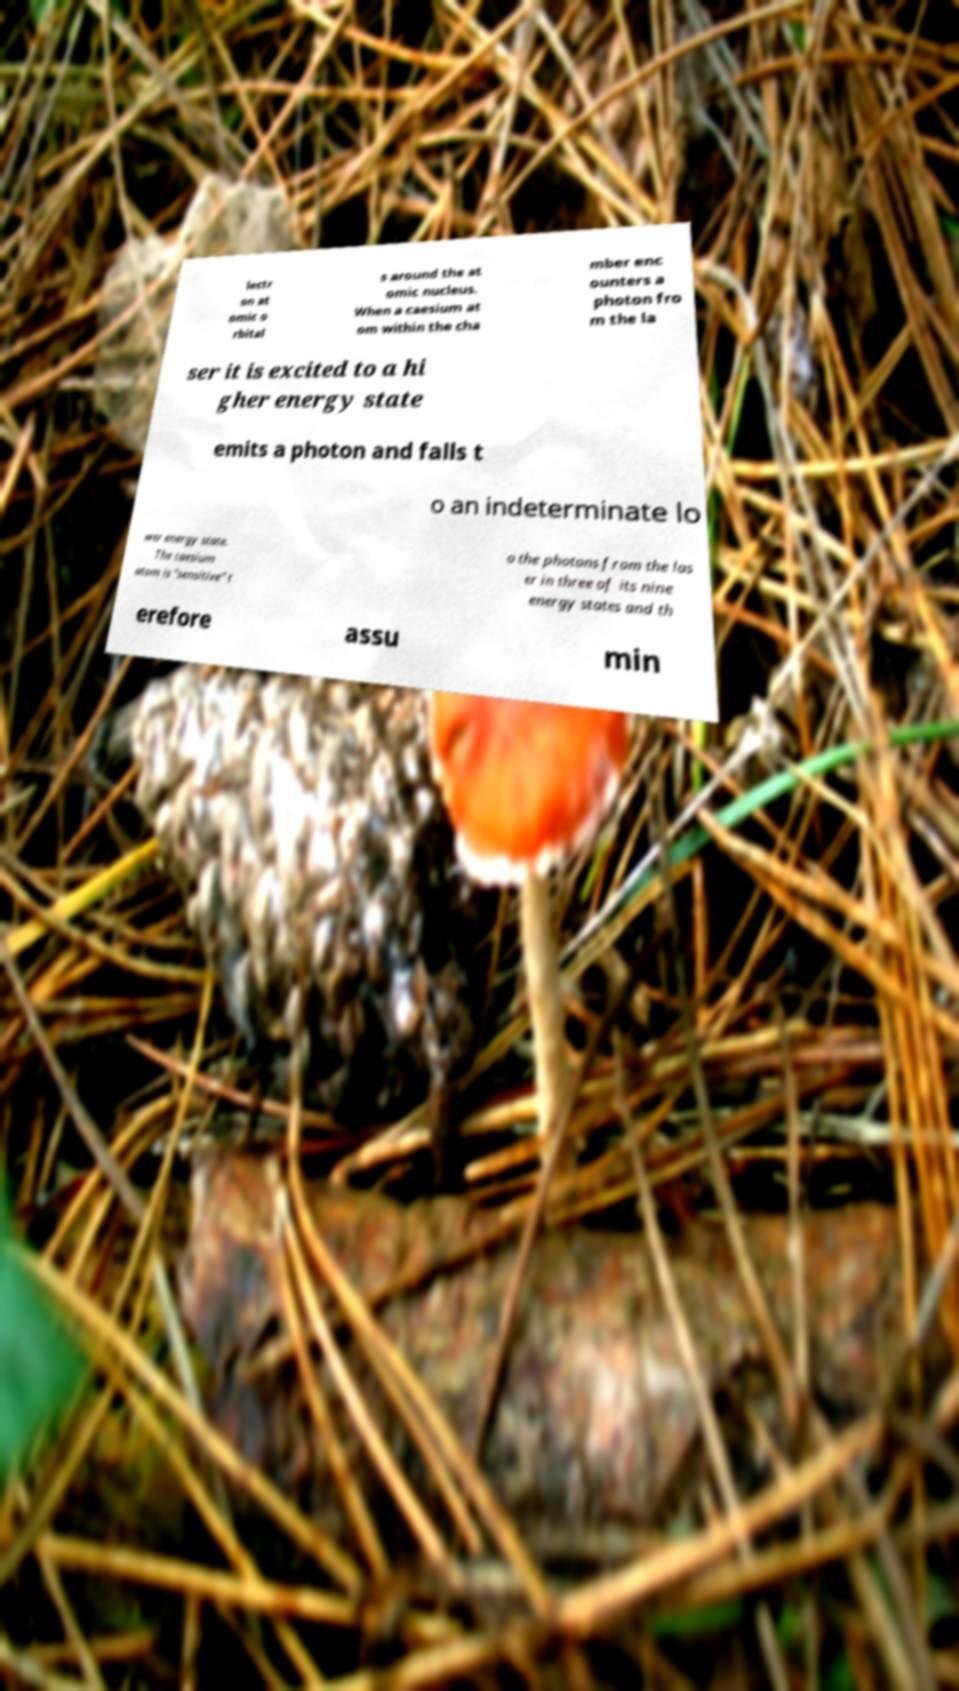I need the written content from this picture converted into text. Can you do that? lectr on at omic o rbital s around the at omic nucleus. When a caesium at om within the cha mber enc ounters a photon fro m the la ser it is excited to a hi gher energy state emits a photon and falls t o an indeterminate lo wer energy state. The caesium atom is "sensitive" t o the photons from the las er in three of its nine energy states and th erefore assu min 